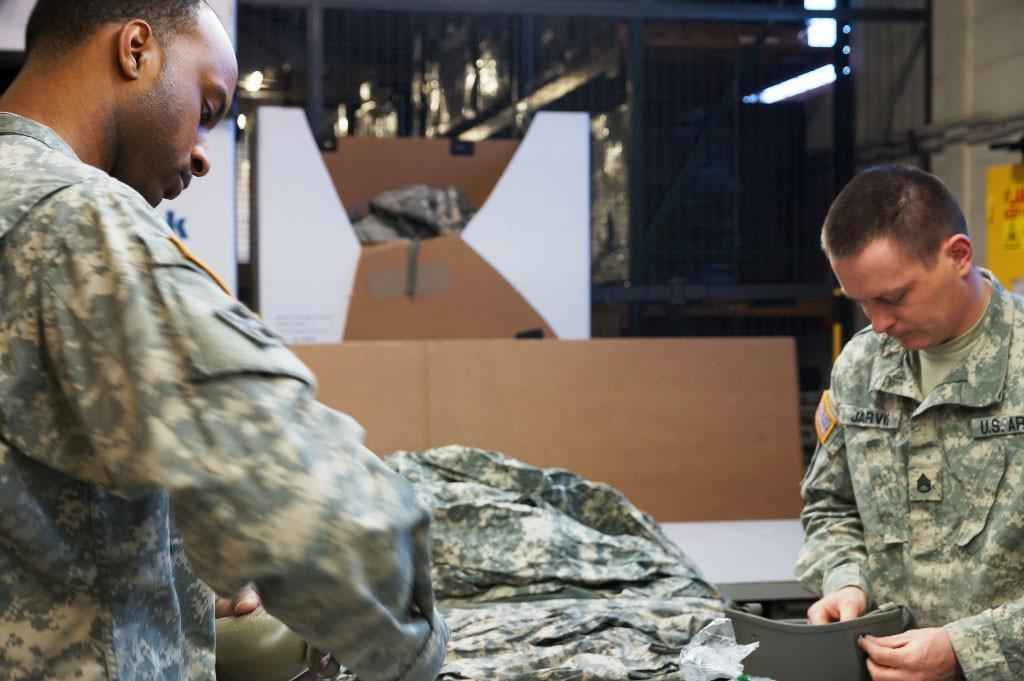How many people are in the image? There are two men in the image. What are the men doing in the image? The men are holding objects. Can you describe the material visible in the image? There is cloth visible in the image. What else can be seen in the image besides the men and cloth? There are boards and other objects in the image. What is visible in the background of the image? There is mesh and lights in the background of the image. What time of day is it in the image, and what are the men teaching? The time of day cannot be determined from the image, and there is no indication that the men are teaching anything. 